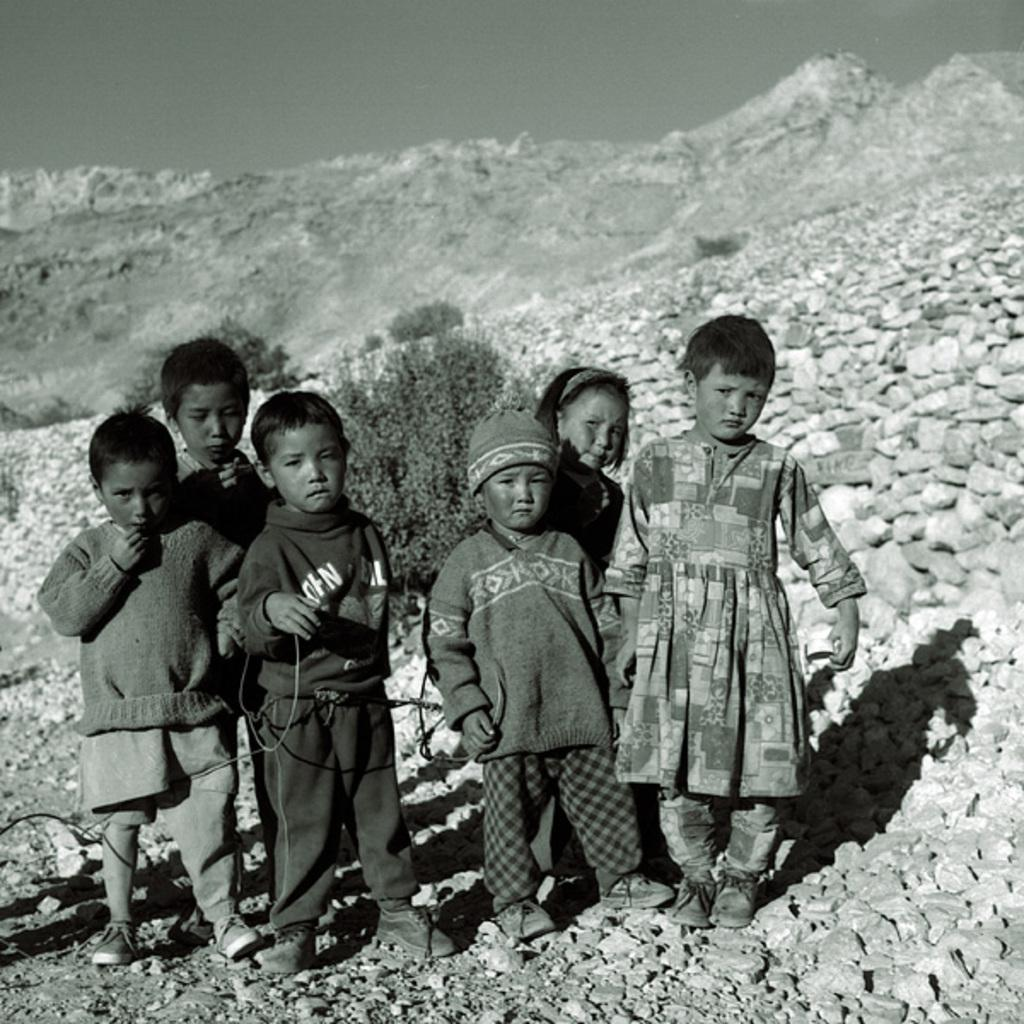What can be seen in the image regarding people? There are kids standing in the image. Can you describe the clothing of one of the kids? A boy is wearing a cap in the image. What type of landscape is visible in the image? There is a hill visible in the image. What is present on the ground in the image? There are stones and plants on the ground in the image. What type of industry can be seen in the background of the image? There is no industry visible in the image; it features kids standing near a hill with stones and plants on the ground. Can you describe the feather that is part of the boy's outfit in the image? There is no feather mentioned or visible in the boy's outfit in the image. 